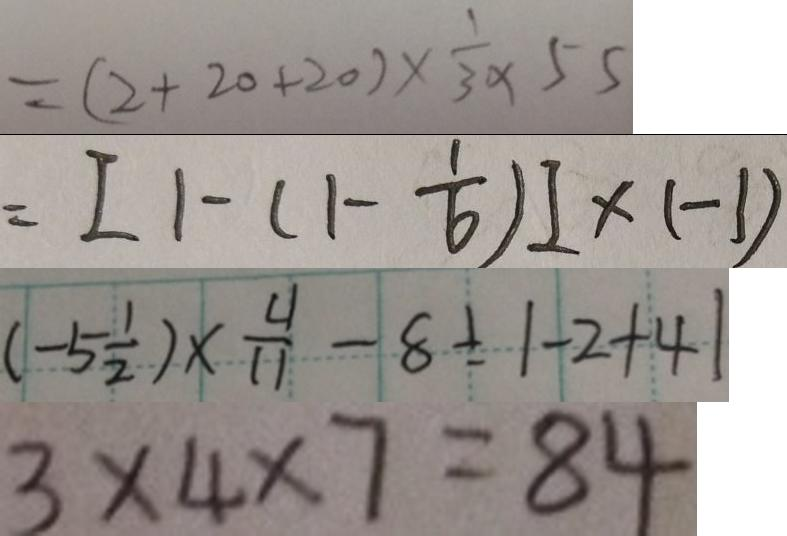<formula> <loc_0><loc_0><loc_500><loc_500>= ( 2 + 2 0 + 2 0 ) \times \frac { 1 } { 3 } \times 5 5 
 = [ 1 - ( 1 - \frac { 1 } { 6 } ) ] \times ( - 1 ) 
 ( - 5 \frac { 1 } { 2 } ) \times \frac { 4 } { 1 1 } - 8 \div \vert - 2 + 4 \vert 
 3 \times 4 \times 7 = 8 4</formula> 